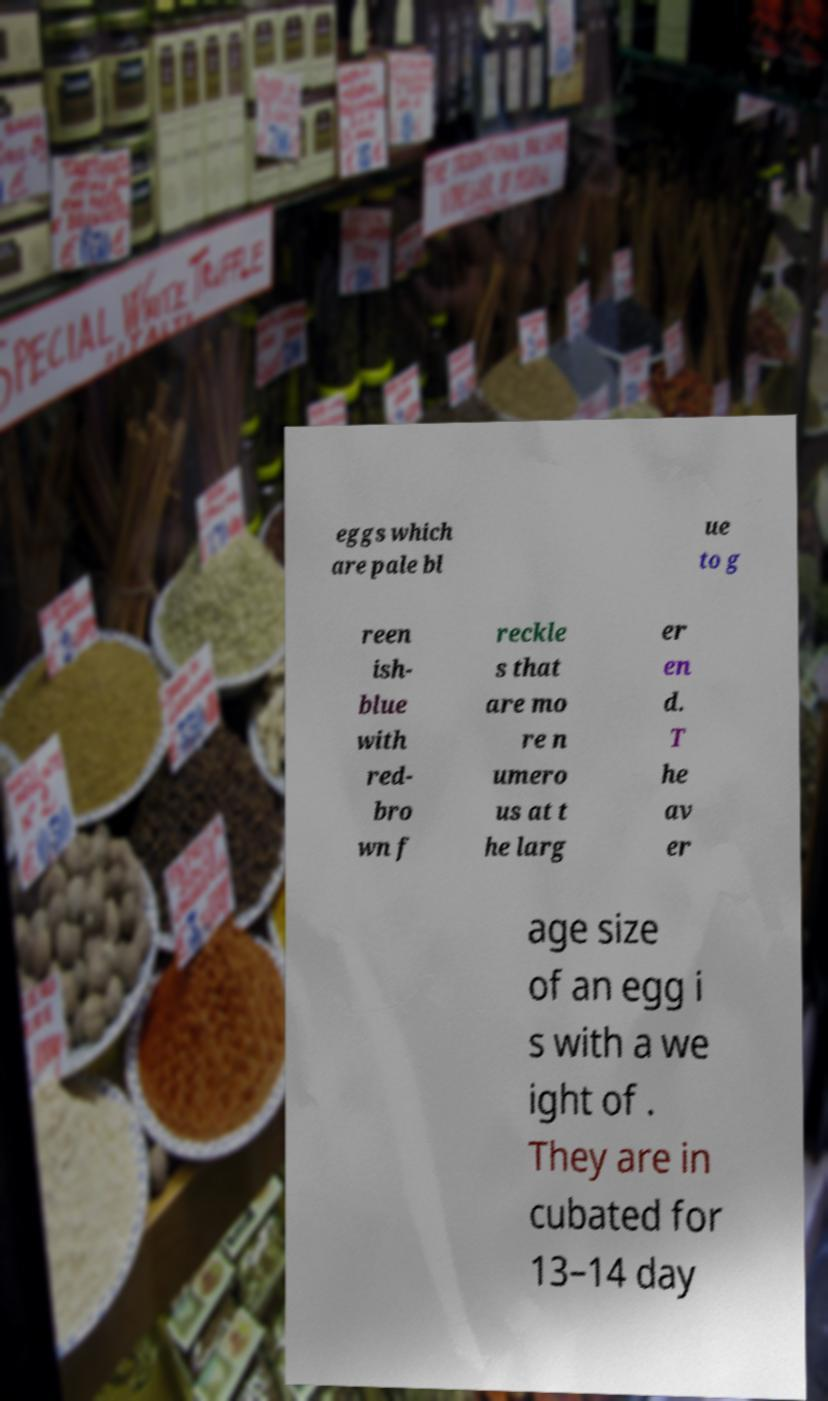Please identify and transcribe the text found in this image. eggs which are pale bl ue to g reen ish- blue with red- bro wn f reckle s that are mo re n umero us at t he larg er en d. T he av er age size of an egg i s with a we ight of . They are in cubated for 13–14 day 